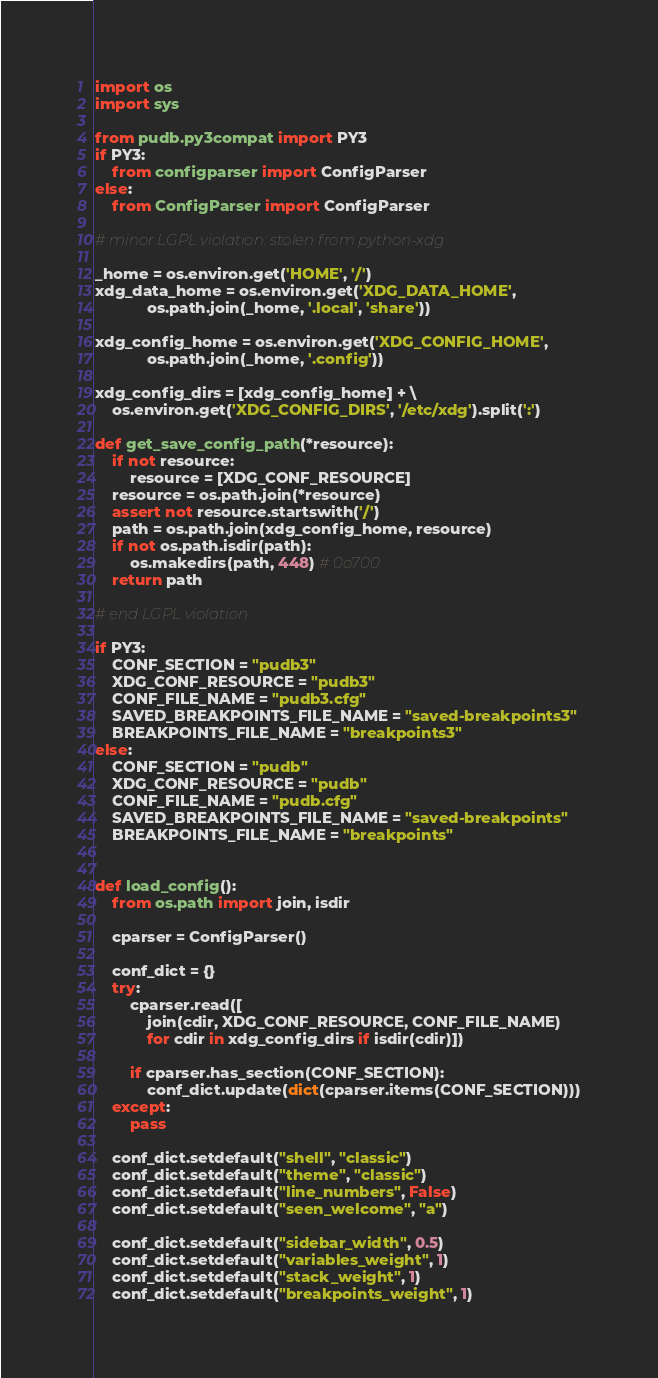Convert code to text. <code><loc_0><loc_0><loc_500><loc_500><_Python_>import os
import sys

from pudb.py3compat import PY3
if PY3:
    from configparser import ConfigParser
else:
    from ConfigParser import ConfigParser

# minor LGPL violation: stolen from python-xdg

_home = os.environ.get('HOME', '/')
xdg_data_home = os.environ.get('XDG_DATA_HOME',
            os.path.join(_home, '.local', 'share'))

xdg_config_home = os.environ.get('XDG_CONFIG_HOME',
            os.path.join(_home, '.config'))

xdg_config_dirs = [xdg_config_home] + \
    os.environ.get('XDG_CONFIG_DIRS', '/etc/xdg').split(':')

def get_save_config_path(*resource):
    if not resource:
        resource = [XDG_CONF_RESOURCE]
    resource = os.path.join(*resource)
    assert not resource.startswith('/')
    path = os.path.join(xdg_config_home, resource)
    if not os.path.isdir(path):
        os.makedirs(path, 448) # 0o700
    return path

# end LGPL violation

if PY3:
    CONF_SECTION = "pudb3"
    XDG_CONF_RESOURCE = "pudb3"
    CONF_FILE_NAME = "pudb3.cfg"
    SAVED_BREAKPOINTS_FILE_NAME = "saved-breakpoints3"
    BREAKPOINTS_FILE_NAME = "breakpoints3"
else:
    CONF_SECTION = "pudb"
    XDG_CONF_RESOURCE = "pudb"
    CONF_FILE_NAME = "pudb.cfg"
    SAVED_BREAKPOINTS_FILE_NAME = "saved-breakpoints"
    BREAKPOINTS_FILE_NAME = "breakpoints"


def load_config():
    from os.path import join, isdir

    cparser = ConfigParser()

    conf_dict = {}
    try:
        cparser.read([
            join(cdir, XDG_CONF_RESOURCE, CONF_FILE_NAME)
            for cdir in xdg_config_dirs if isdir(cdir)])

        if cparser.has_section(CONF_SECTION):
            conf_dict.update(dict(cparser.items(CONF_SECTION)))
    except:
        pass

    conf_dict.setdefault("shell", "classic")
    conf_dict.setdefault("theme", "classic")
    conf_dict.setdefault("line_numbers", False)
    conf_dict.setdefault("seen_welcome", "a")

    conf_dict.setdefault("sidebar_width", 0.5)
    conf_dict.setdefault("variables_weight", 1)
    conf_dict.setdefault("stack_weight", 1)
    conf_dict.setdefault("breakpoints_weight", 1)
</code> 